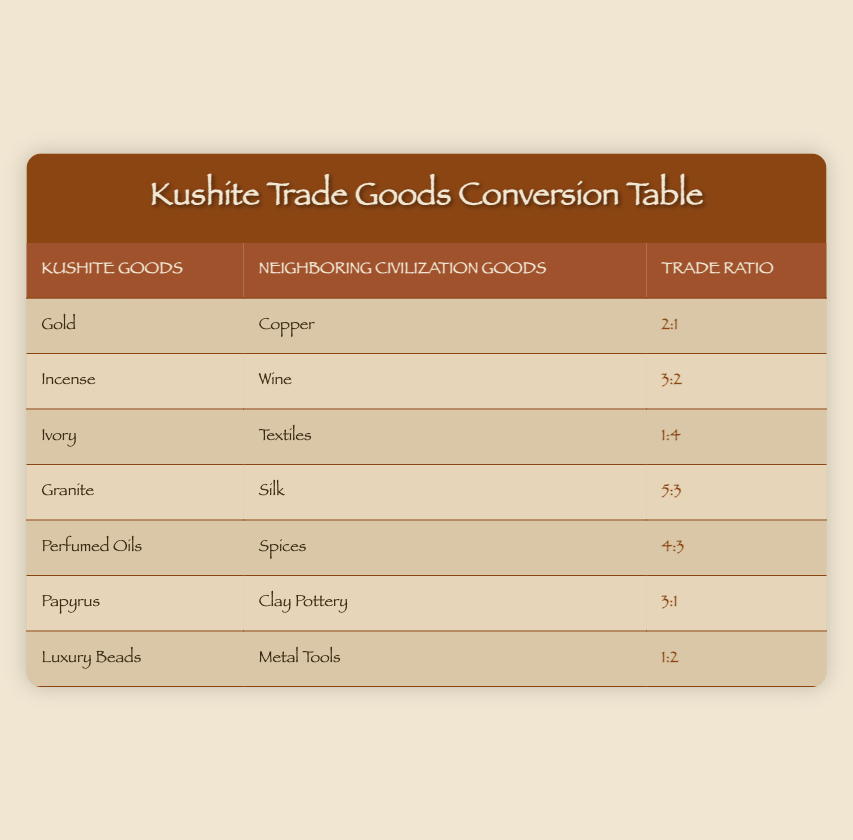What Kushite good is traded for copper? The table lists "Gold" in the first row as the Kushite good exchanged for "Copper," along with a trade ratio of 2:1, indicating that 2 units of Gold are traded for 1 unit of Copper.
Answer: Gold What is the trade ratio between Incense and Wine? The trade ratio is shown in the second row of the table, which indicates that the ratio between Incense and Wine is 3:2, meaning 3 units of Incense are exchanged for 2 units of Wine.
Answer: 3:2 Is the trade of Ivory for textiles more favorable for the Kushites or the neighboring civilization? The ratio of 1:4 indicates that it takes 4 units of textiles to obtain just 1 unit of Ivory. This is less favorable for the Kushites, as they must give up much of their valuable resource to obtain textiles.
Answer: No What are the Kushite goods that can be exchanged for 3 units of Neighboring Civilization goods? The relevant rows have to be examined: Incense has a 3:2 ratio, which implies that trading 3 units of Incense gives 2 units of Wine. Also, Papyrus can be traded at a ratio of 3:1, exchanging 3 units of Papyrus for 1 unit of Clay Pottery. Hence, Kushite goods giving such exchanges are Incense and Papyrus.
Answer: Incense, Papyrus Which trade involves the most Kushite goods for the fewest neighboring goods? In the table, the trade involving the fewest neighboring goods for the most Kushite goods is that of Ivory for Textiles, where the ratio is 1:4. Thus, only 1 unit of Ivory yields 4 units of Textiles.
Answer: Ivory for Textiles How many total units of goods are exchanged when trading Papyrus? The table shows that 3 units of Papyrus are exchanged for 1 unit of Clay Pottery. Thus, a total of 4 units are involved in this transaction (3 Papyrus and 1 Clay Pottery).
Answer: 4 Compare the ratios of Perfumed Oils to Spices and Granite to Silk. Which is a better trade for the Kushites? The trade ratio for Perfumed Oils to Spices is 4:3, which means the Kushites give away 4 units of Perfumed Oils for 3 units of Spices. The Granite to Silk ratio is 5:3, indicating 5 units of Granite received for 3 units of Silk. To compare, the Kushites lose more with Granite, as they give 5 for 3, compared to 4 for 3 in the other trade. Hence, Perfumed Oils for Spices is the better deal.
Answer: Perfumed Oils for Spices What is the sum of trade ratios of all the goods? To find the total ratio involves transcribing the fractions: Gold (2:1), Incense (3:2), Ivory (1:4), Granite (5:3), Perfumed Oils (4:3), Papyrus (3:1), and Luxury Beads (1:2). By adding individually, the total of the Kushite goods (2 + 3 + 1 + 5 + 4 + 3 + 1) equals 19, while the total of neighboring goods (1 + 2 + 4 + 3 + 3 + 1 + 2) equals 16. Hence, the sum of trade ratios is 19:16.
Answer: 19:16 